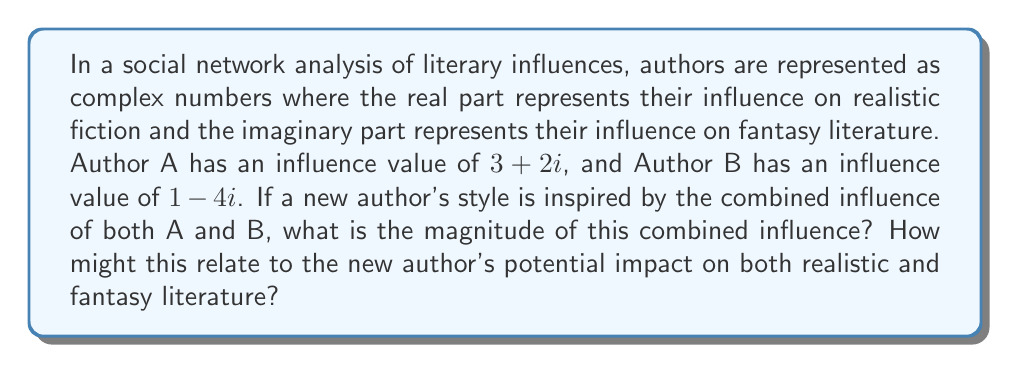Could you help me with this problem? To solve this problem, we'll follow these steps:

1) First, we need to add the complex numbers representing Authors A and B:
   $$(3 + 2i) + (1 - 4i) = (3 + 1) + (2 - 4)i = 4 - 2i$$

2) This sum represents the combined influence of Authors A and B on the new author.

3) To find the magnitude of this combined influence, we use the formula for the absolute value (or modulus) of a complex number:
   
   For a complex number $a + bi$, the magnitude is given by $\sqrt{a^2 + b^2}$

4) In this case, we have $4 - 2i$, so $a = 4$ and $b = -2$

5) Plugging these values into the formula:

   $$\sqrt{4^2 + (-2)^2} = \sqrt{16 + 4} = \sqrt{20} = 2\sqrt{5}$$

6) Interpreting the result:
   - The magnitude $2\sqrt{5}$ represents the overall strength of the combined influence.
   - The real part (4) being positive and larger than the absolute value of the imaginary part (-2) suggests a stronger influence on realistic fiction.
   - The negative imaginary part (-2) indicates a counterbalancing influence on fantasy literature.

This result suggests that the new author might have a strong overall literary influence, with a tendency to lean more towards realistic fiction while also incorporating some elements that subvert or contrast with traditional fantasy literature.
Answer: The magnitude of the combined influence is $2\sqrt{5}$. 